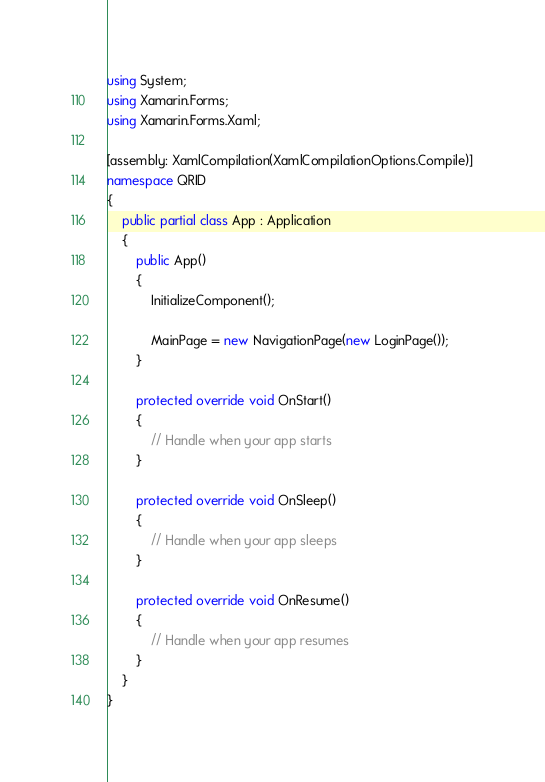<code> <loc_0><loc_0><loc_500><loc_500><_C#_>using System;
using Xamarin.Forms;
using Xamarin.Forms.Xaml;

[assembly: XamlCompilation(XamlCompilationOptions.Compile)]
namespace QRID
{
    public partial class App : Application
    {
        public App()
        {
            InitializeComponent();

            MainPage = new NavigationPage(new LoginPage());
        }

        protected override void OnStart()
        {
            // Handle when your app starts
        }

        protected override void OnSleep()
        {
            // Handle when your app sleeps
        }

        protected override void OnResume()
        {
            // Handle when your app resumes
        }
    }
}
</code> 